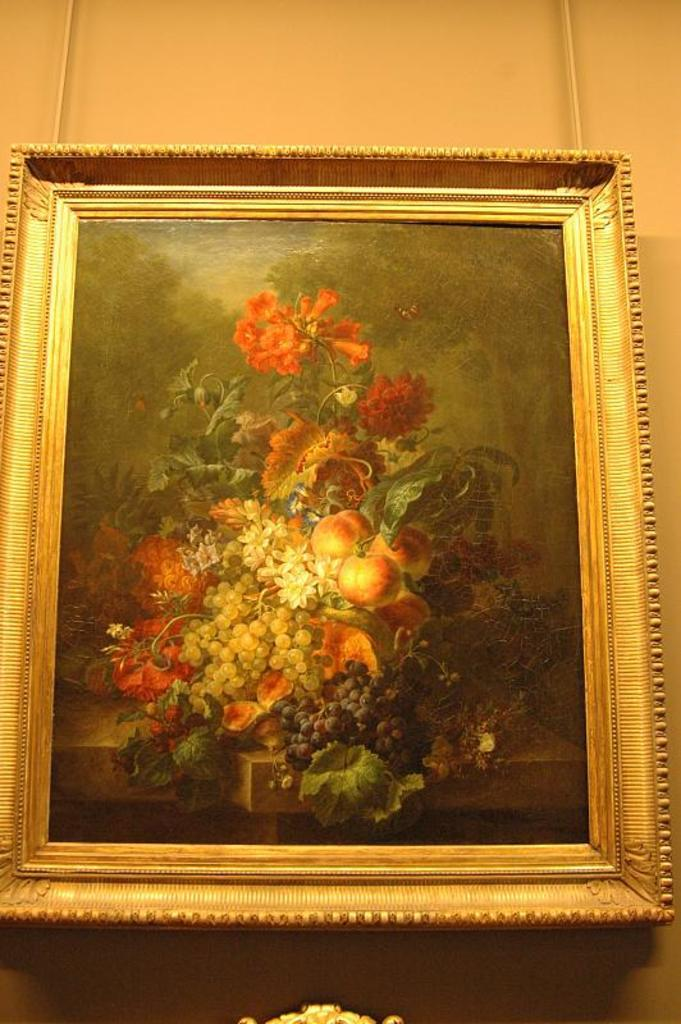What object can be seen in the image that is typically used for displaying photos? There is a photo frame in the image. Where is the photo frame located? The photo frame is on a wall. What type of honey is being used to treat the disease in the image? There is no honey or disease present in the image; it only features a photo frame on a wall. 